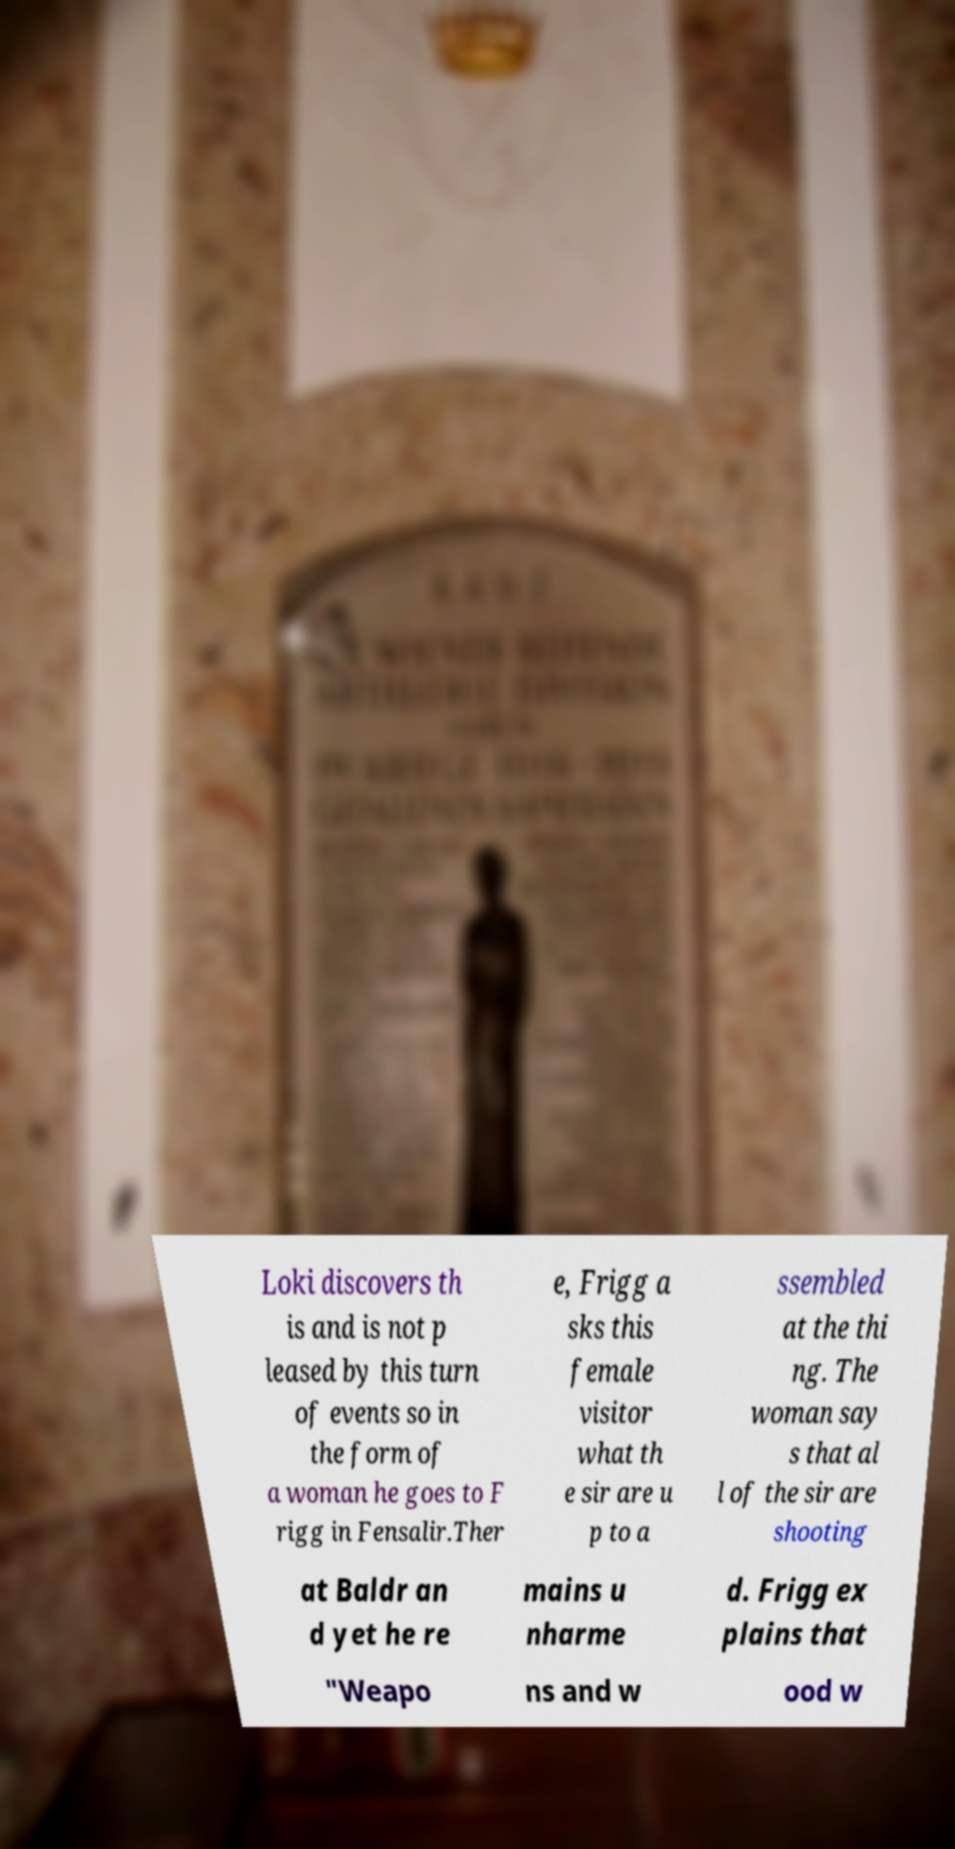Could you extract and type out the text from this image? Loki discovers th is and is not p leased by this turn of events so in the form of a woman he goes to F rigg in Fensalir.Ther e, Frigg a sks this female visitor what th e sir are u p to a ssembled at the thi ng. The woman say s that al l of the sir are shooting at Baldr an d yet he re mains u nharme d. Frigg ex plains that "Weapo ns and w ood w 